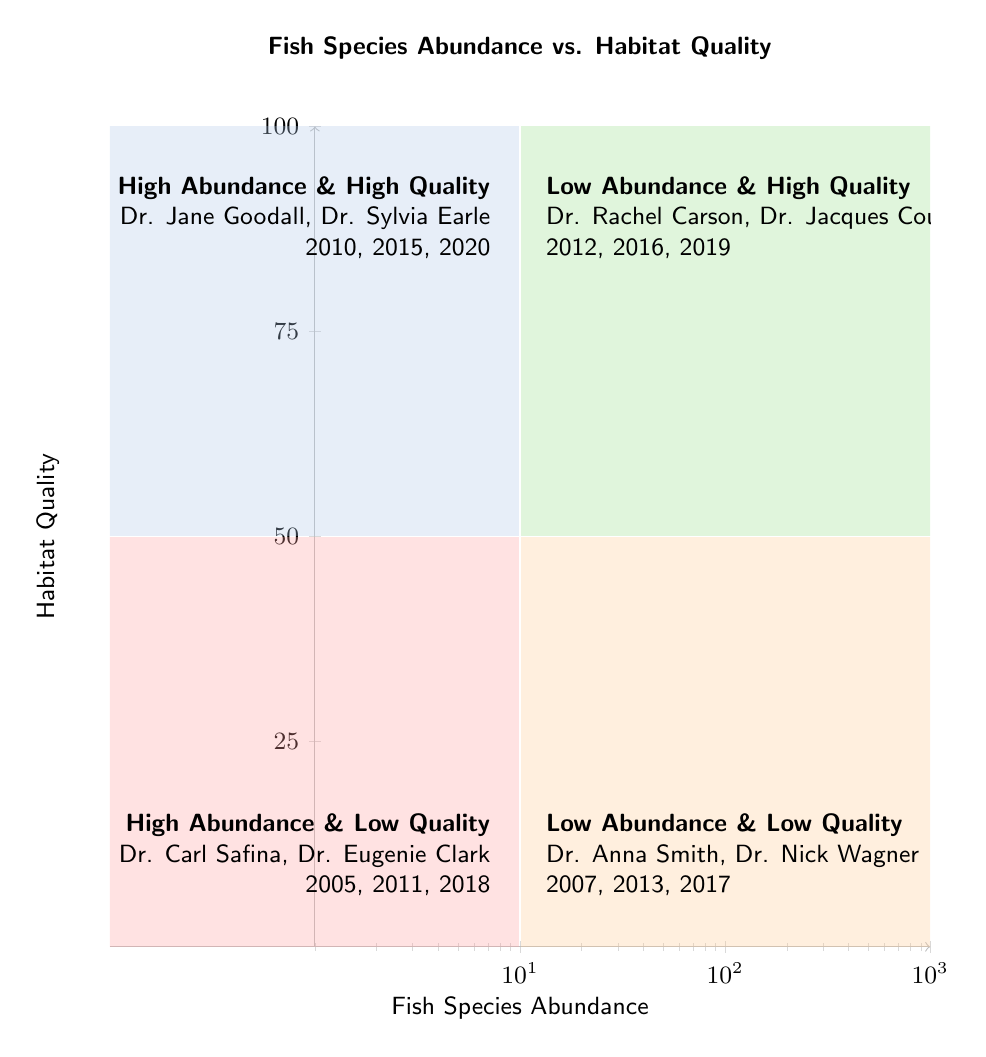What partners are associated with high abundance and high quality? The quadrant labeled "High Abundance & High Quality" contains the partners Dr. Jane Goodall and Dr. Sylvia Earle.
Answer: Dr. Jane Goodall, Dr. Sylvia Earle What years are represented in the low abundance and low quality quadrant? The quadrant labeled "Low Abundance & Low Quality" lists the years 2007, 2013, and 2017.
Answer: 2007, 2013, 2017 Which quadrant has the highest habitat quality? The "High Abundance & High Quality" quadrant represents the combination of both high fish species abundance and high habitat quality, making it the quadrant with the highest habitat quality.
Answer: High Abundance & High Quality How many partners contributed to studies in the high abundance and low quality quadrant? The quadrant "High Abundance & Low Quality" contains two partners: Dr. Carl Safina and Dr. Eugenie Clark, so the total count is 2.
Answer: 2 Which quadrant includes Dr. Rachel Carson? Dr. Rachel Carson is associated with the "Low Abundance & High Quality" quadrant.
Answer: Low Abundance & High Quality What is the relationship between habitat quality and partner contributions in the context of this diagram? In this diagram, as habitat quality increases, particularly in the "High Abundance & High Quality" quadrant, more influential partners like Dr. Jane Goodall and Dr. Sylvia Earle are present, indicating a link between higher habitat quality and significant contributions from renowned partners.
Answer: Higher quality, more contributions How many total years of study are represented across all quadrants? The years of study are listed as 2010, 2015, 2020 (3 years), 2005, 2011, 2018 (3 years), 2012, 2016, 2019 (3 years), and 2007, 2013, 2017 (3 years), which totals 12 years of study across all quadrants.
Answer: 12 What quadrant is characterized by low abundance and high quality? The quadrant specifically labeled "Low Abundance & High Quality" highlights this combination of characteristics.
Answer: Low Abundance & High Quality Which quadrant references Dr. Carl Safina? Dr. Carl Safina is listed under the "High Abundance & Low Quality" quadrant of the diagram.
Answer: High Abundance & Low Quality 